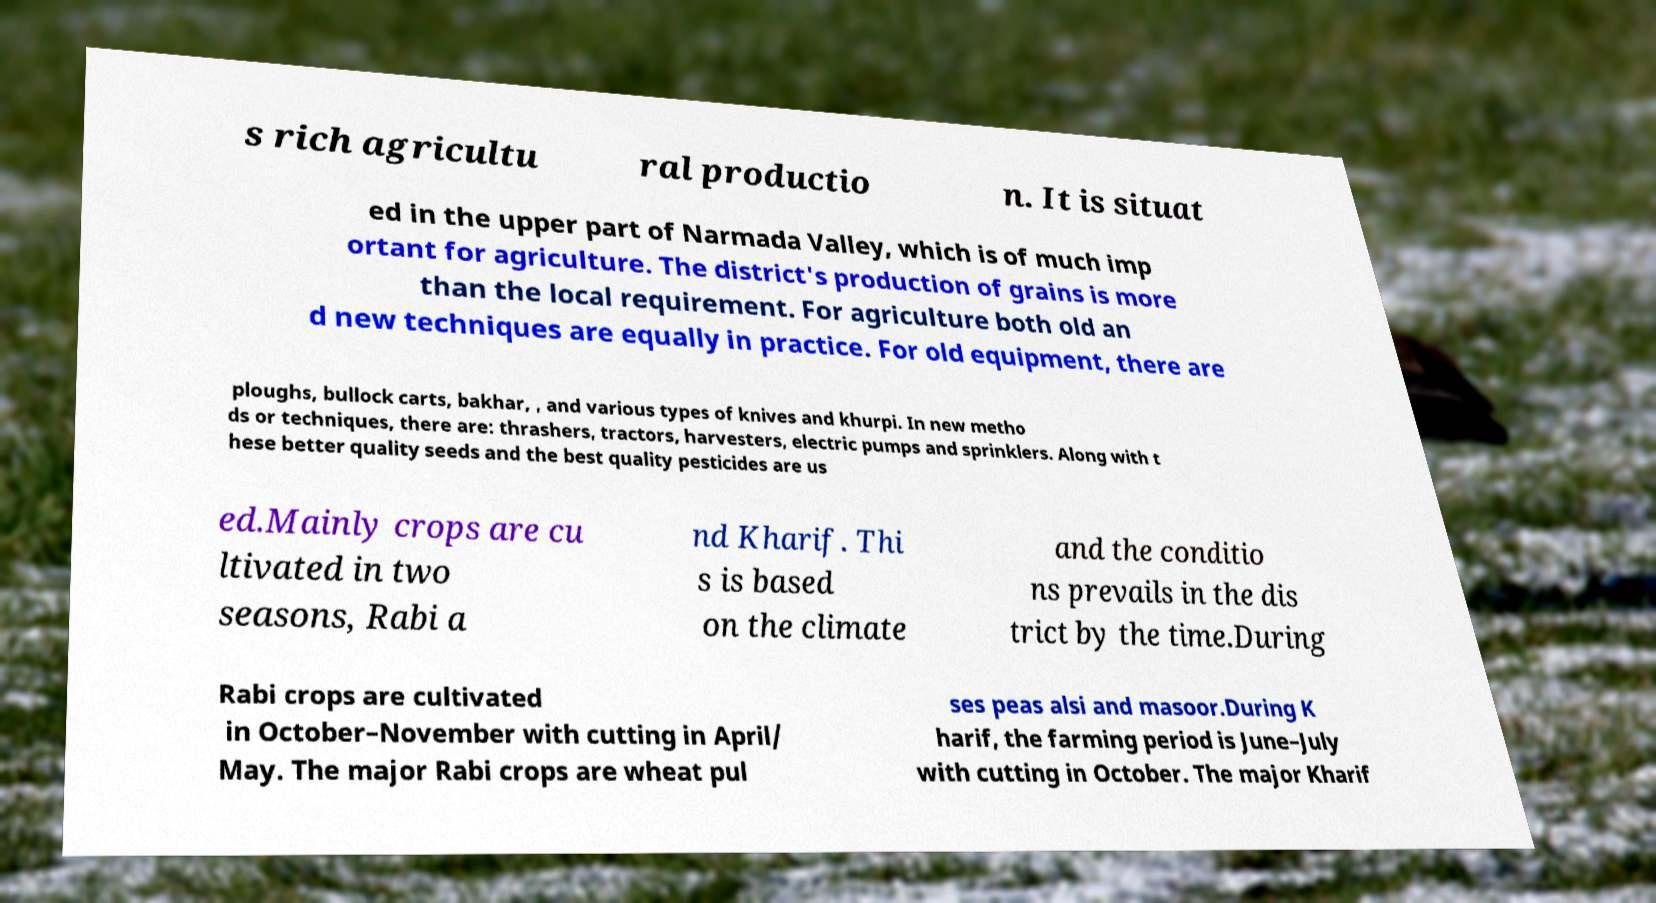Can you read and provide the text displayed in the image?This photo seems to have some interesting text. Can you extract and type it out for me? s rich agricultu ral productio n. It is situat ed in the upper part of Narmada Valley, which is of much imp ortant for agriculture. The district's production of grains is more than the local requirement. For agriculture both old an d new techniques are equally in practice. For old equipment, there are ploughs, bullock carts, bakhar, , and various types of knives and khurpi. In new metho ds or techniques, there are: thrashers, tractors, harvesters, electric pumps and sprinklers. Along with t hese better quality seeds and the best quality pesticides are us ed.Mainly crops are cu ltivated in two seasons, Rabi a nd Kharif. Thi s is based on the climate and the conditio ns prevails in the dis trict by the time.During Rabi crops are cultivated in October–November with cutting in April/ May. The major Rabi crops are wheat pul ses peas alsi and masoor.During K harif, the farming period is June–July with cutting in October. The major Kharif 